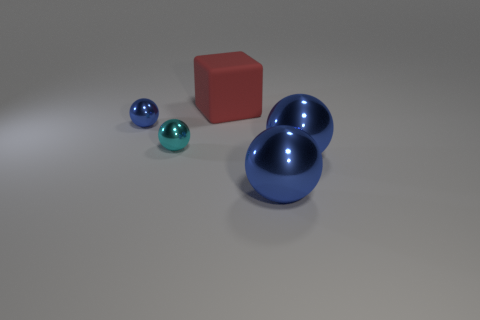Add 2 big blue spheres. How many objects exist? 7 Subtract all blue shiny balls. How many balls are left? 1 Add 1 large blue cylinders. How many large blue cylinders exist? 1 Subtract all blue spheres. How many spheres are left? 1 Subtract 0 green cubes. How many objects are left? 5 Subtract all cubes. How many objects are left? 4 Subtract 1 balls. How many balls are left? 3 Subtract all red spheres. Subtract all green blocks. How many spheres are left? 4 Subtract all red balls. How many gray blocks are left? 0 Subtract all big purple rubber things. Subtract all big matte blocks. How many objects are left? 4 